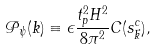Convert formula to latex. <formula><loc_0><loc_0><loc_500><loc_500>\mathcal { P } _ { \psi } ( k ) \equiv \epsilon \frac { t _ { p } ^ { 2 } H ^ { 2 } } { 8 \pi ^ { 2 } } C ( s _ { \vec { k } } ^ { c } ) ,</formula> 